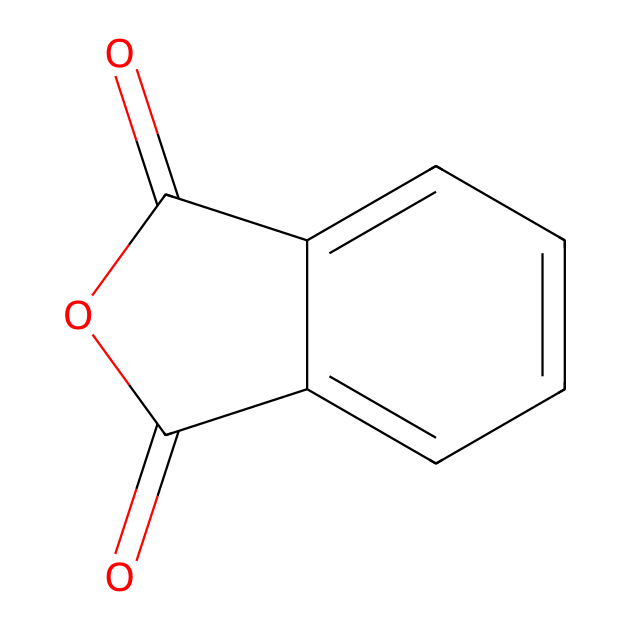What is the molecular formula of phthalic anhydride? By analyzing the SMILES representation, we can count the carbon (C), hydrogen (H), and oxygen (O) atoms. The structure indicates 8 carbon atoms, 4 oxygen atoms, and 4 hydrogen atoms. Therefore, the molecular formula is C8H4O3.
Answer: C8H4O3 How many rings are present in phthalic anhydride? The structure contains a cyclic component where part of the molecule is made up of a benzene ring fused with another cycle that includes two carbonyl groups and an oxygen. Thus, there is one ring in the structure.
Answer: 1 What type of chemical compound is phthalic anhydride? Given that it contains two acyl groups (carbonyls) and one oxygen that connects the two acyl groups, it fits the definition of an acid anhydride, which typically arises from the condensation of two carboxylic acids.
Answer: acid anhydride What is the total number of double bonds in phthalic anhydride? Examining the structure reveals that there are two double bonds within the carbonyl groups (C=O) and another double bond in the aromatic ring, making for a total of three double bonds present in the molecule.
Answer: 3 What functional groups are present in phthalic anhydride? The key functional groups identifiable in this structure are the anhydride functional group (shown by the -O-C(=O)-) and phenyl groups (the benzene ring). Together, these define the reactivity and properties of phthalic anhydride.
Answer: anhydride and phenyl What is the primary use of phthalic anhydride in the medical field? Phthalic anhydride is mainly used for the synthesis of plasticizers which enhance the flexibility, transparency, and durability of plastics, including those used in medical devices. This is critical for the performance and safety of such devices.
Answer: plasticizers 